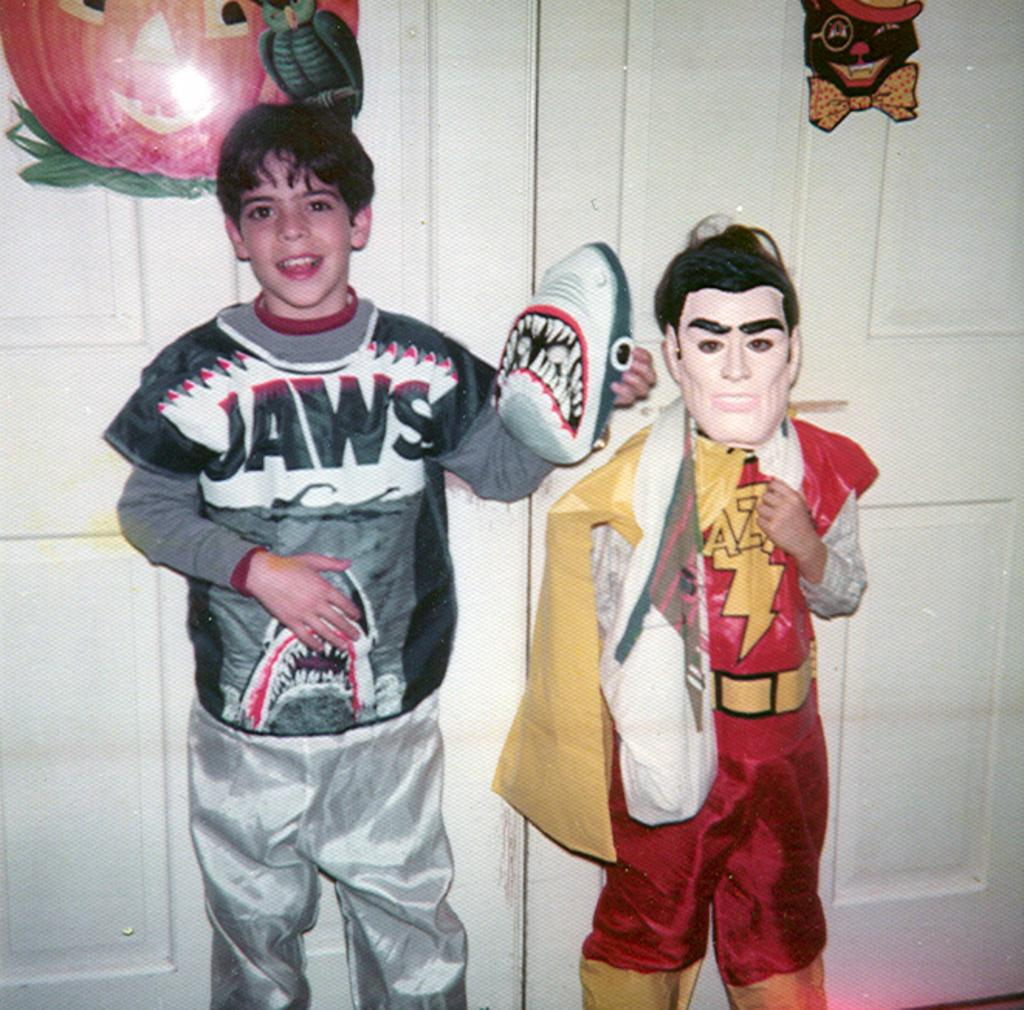<image>
Render a clear and concise summary of the photo. Two children wearing costumes, one has a Jaws outfit. 